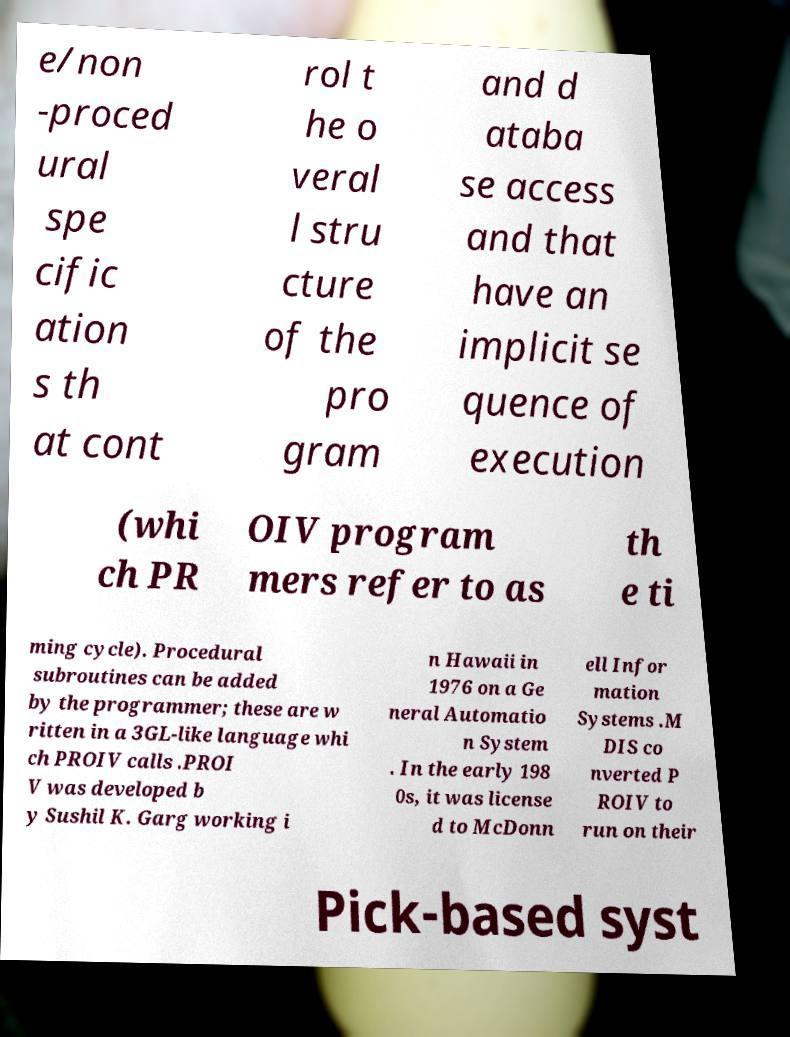I need the written content from this picture converted into text. Can you do that? e/non -proced ural spe cific ation s th at cont rol t he o veral l stru cture of the pro gram and d ataba se access and that have an implicit se quence of execution (whi ch PR OIV program mers refer to as th e ti ming cycle). Procedural subroutines can be added by the programmer; these are w ritten in a 3GL-like language whi ch PROIV calls .PROI V was developed b y Sushil K. Garg working i n Hawaii in 1976 on a Ge neral Automatio n System . In the early 198 0s, it was license d to McDonn ell Infor mation Systems .M DIS co nverted P ROIV to run on their Pick-based syst 